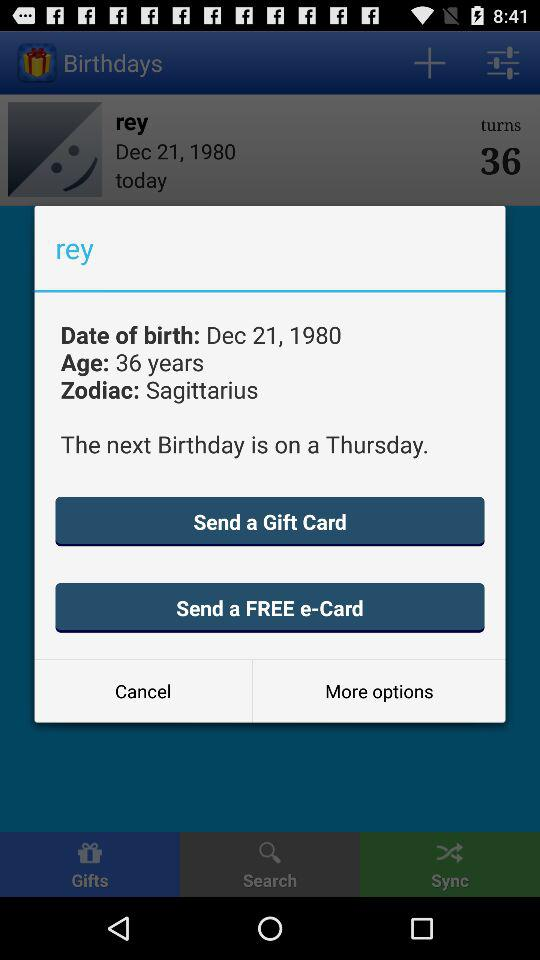What is the age of Rey? The age is 36 years. 